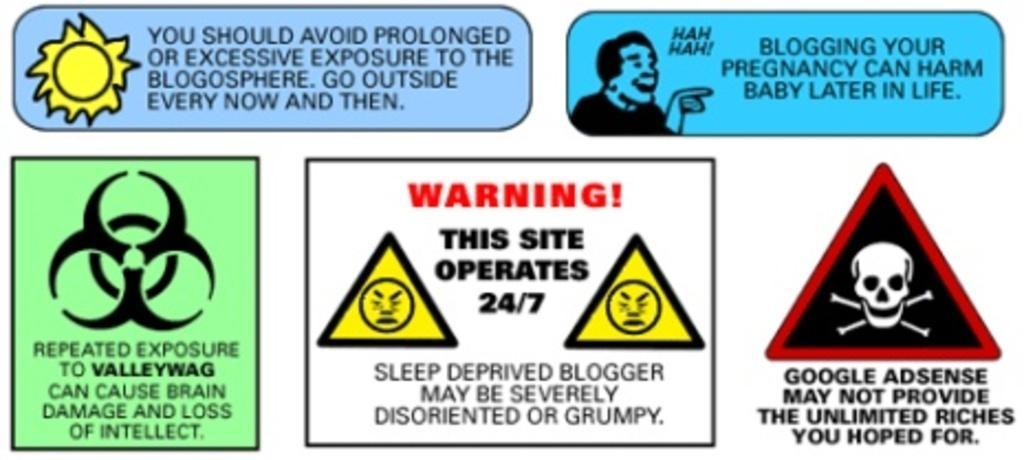Can you describe this image briefly? In this image we can see a poster with some sign symbols and warnings and we can see some text on the poster. 